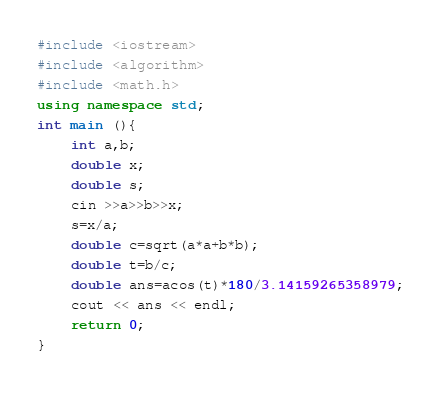<code> <loc_0><loc_0><loc_500><loc_500><_C++_>#include <iostream>
#include <algorithm>
#include <math.h>
using namespace std;
int main (){
    int a,b;
    double x;
    double s;
    cin >>a>>b>>x;
    s=x/a;
    double c=sqrt(a*a+b*b);
    double t=b/c;
    double ans=acos(t)*180/3.14159265358979;
    cout << ans << endl;
    return 0;
}</code> 